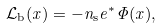Convert formula to latex. <formula><loc_0><loc_0><loc_500><loc_500>\mathcal { L } _ { \text  b}(x)=-n_{\text {s} } e ^ { * } \Phi ( x ) ,</formula> 